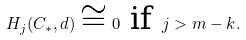Convert formula to latex. <formula><loc_0><loc_0><loc_500><loc_500>H _ { j } ( C _ { \ast } , d ) \cong 0 \text { if } j > m - k .</formula> 